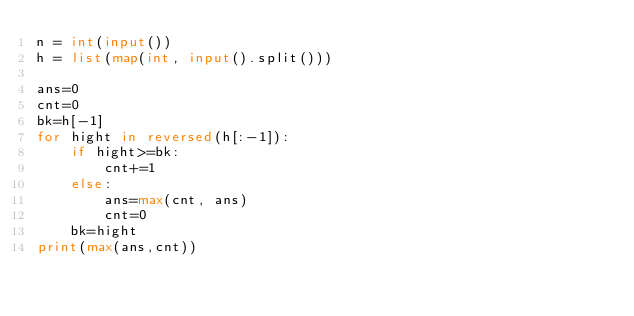Convert code to text. <code><loc_0><loc_0><loc_500><loc_500><_Python_>n = int(input())
h = list(map(int, input().split()))

ans=0
cnt=0
bk=h[-1]
for hight in reversed(h[:-1]):
    if hight>=bk:
        cnt+=1
    else:
        ans=max(cnt, ans)
        cnt=0
    bk=hight
print(max(ans,cnt))</code> 